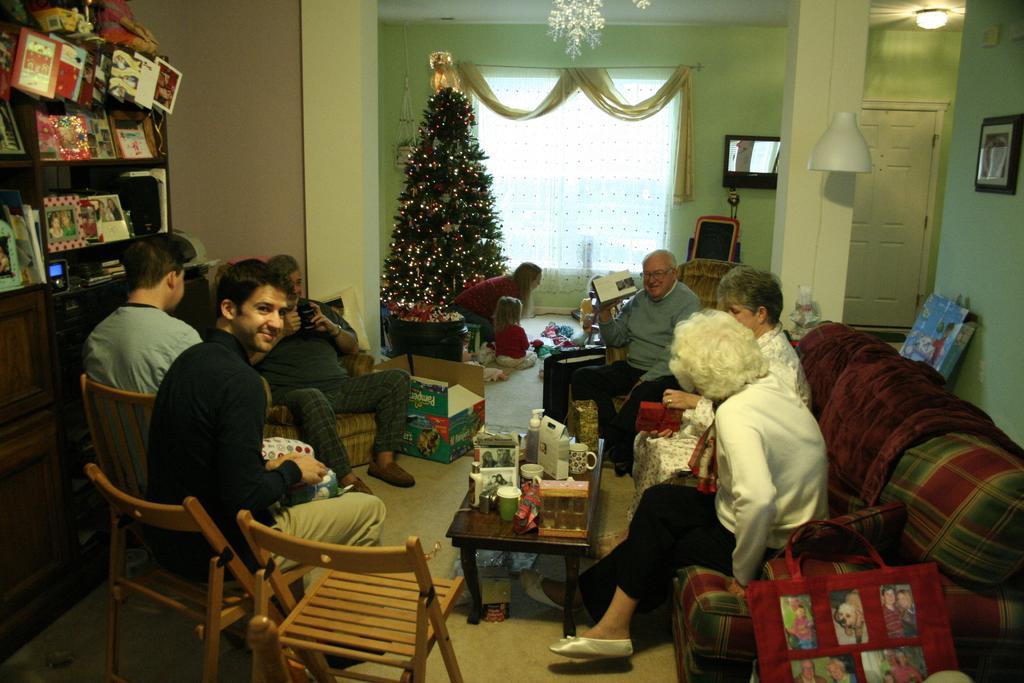Can you describe this image briefly? In this image i can see a group of people are sitting on a chair in front of a table. On the table i can see there are few objects on it. I can also see there is a Christmas tree and a window with a curtain. 